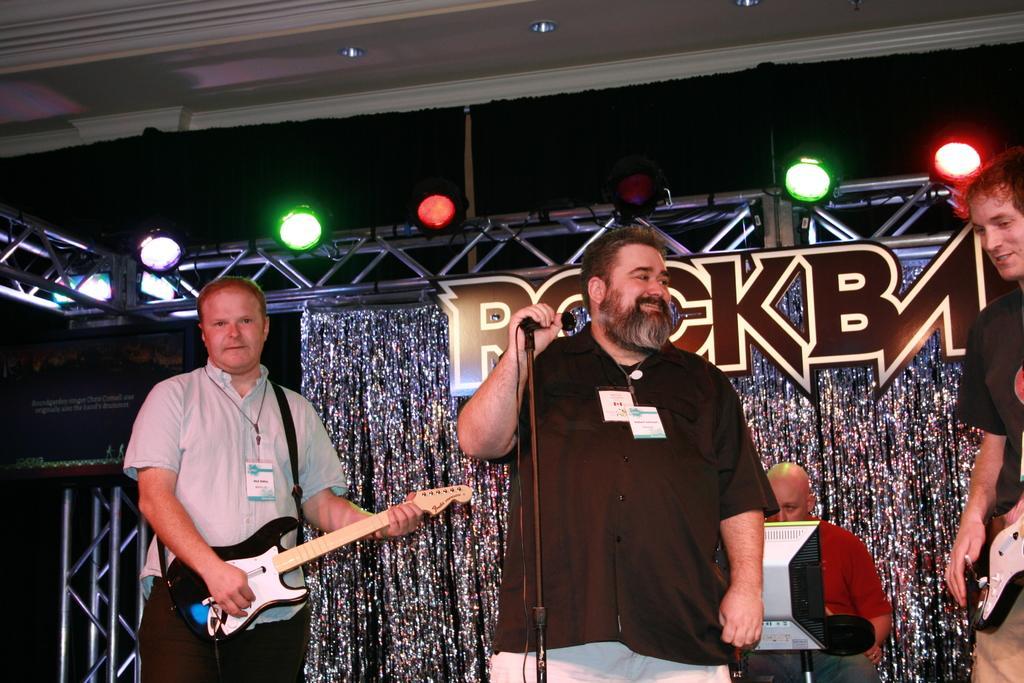Describe this image in one or two sentences. This picture is of inside. On the right corner there is a man holding guitar, smiling and standing. In the center there is a man wearing black color shirt, smiling, holding a microphone and standing. The microphone is attached to the stand, behind him there is a man sitting on the chair and looking at the monitor. On the left there is a man playing guitar and standing. In the background we can see the metal rods and focusing lights. 